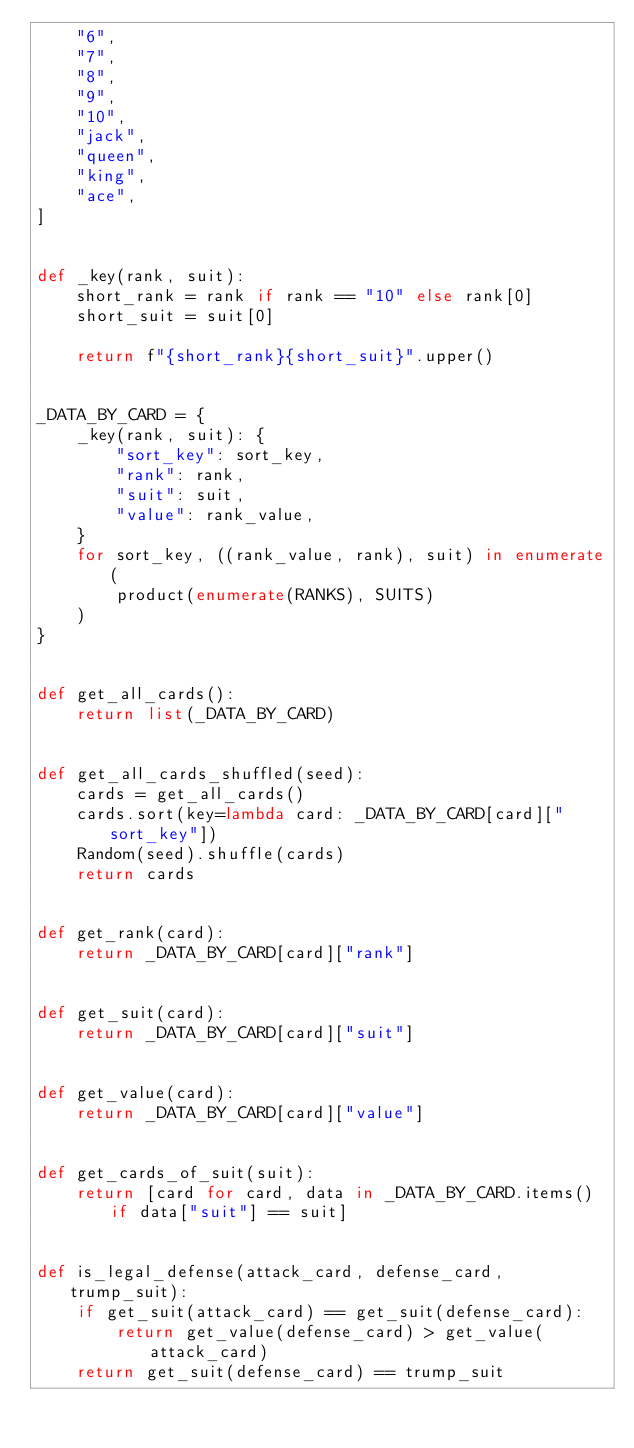Convert code to text. <code><loc_0><loc_0><loc_500><loc_500><_Python_>    "6",
    "7",
    "8",
    "9",
    "10",
    "jack",
    "queen",
    "king",
    "ace",
]


def _key(rank, suit):
    short_rank = rank if rank == "10" else rank[0]
    short_suit = suit[0]

    return f"{short_rank}{short_suit}".upper()


_DATA_BY_CARD = {
    _key(rank, suit): {
        "sort_key": sort_key,
        "rank": rank,
        "suit": suit,
        "value": rank_value,
    }
    for sort_key, ((rank_value, rank), suit) in enumerate(
        product(enumerate(RANKS), SUITS)
    )
}


def get_all_cards():
    return list(_DATA_BY_CARD)


def get_all_cards_shuffled(seed):
    cards = get_all_cards()
    cards.sort(key=lambda card: _DATA_BY_CARD[card]["sort_key"])
    Random(seed).shuffle(cards)
    return cards


def get_rank(card):
    return _DATA_BY_CARD[card]["rank"]


def get_suit(card):
    return _DATA_BY_CARD[card]["suit"]


def get_value(card):
    return _DATA_BY_CARD[card]["value"]


def get_cards_of_suit(suit):
    return [card for card, data in _DATA_BY_CARD.items() if data["suit"] == suit]


def is_legal_defense(attack_card, defense_card, trump_suit):
    if get_suit(attack_card) == get_suit(defense_card):
        return get_value(defense_card) > get_value(attack_card)
    return get_suit(defense_card) == trump_suit
</code> 